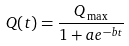Convert formula to latex. <formula><loc_0><loc_0><loc_500><loc_500>Q ( t ) = \frac { Q _ { \max } } { 1 + a e ^ { - b t } }</formula> 